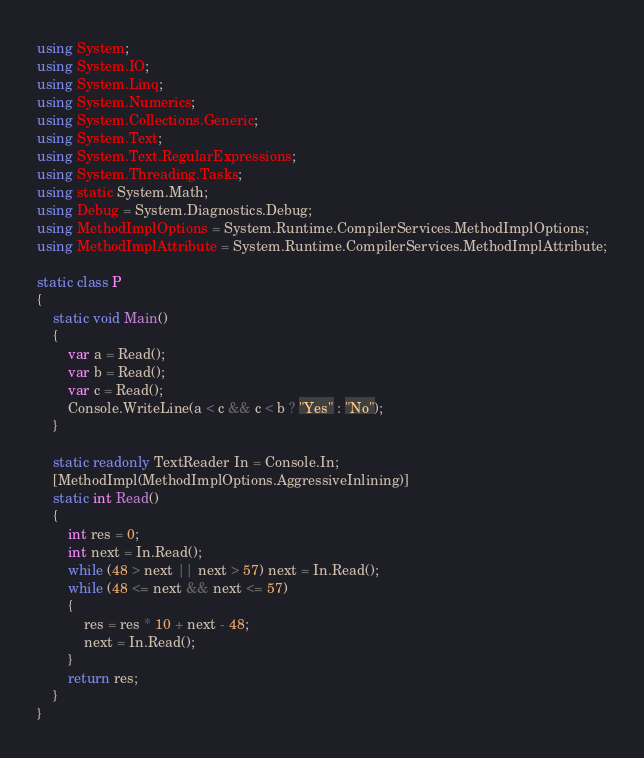Convert code to text. <code><loc_0><loc_0><loc_500><loc_500><_C#_>using System;
using System.IO;
using System.Linq;
using System.Numerics;
using System.Collections.Generic;
using System.Text;
using System.Text.RegularExpressions;
using System.Threading.Tasks;
using static System.Math;
using Debug = System.Diagnostics.Debug;
using MethodImplOptions = System.Runtime.CompilerServices.MethodImplOptions;
using MethodImplAttribute = System.Runtime.CompilerServices.MethodImplAttribute;

static class P
{
    static void Main()
    {
        var a = Read();   
        var b = Read();   
        var c = Read();
        Console.WriteLine(a < c && c < b ? "Yes" : "No");
    }

    static readonly TextReader In = Console.In;
    [MethodImpl(MethodImplOptions.AggressiveInlining)]
    static int Read()
    {
        int res = 0;
        int next = In.Read();
        while (48 > next || next > 57) next = In.Read();
        while (48 <= next && next <= 57)
        {
            res = res * 10 + next - 48;
            next = In.Read();
        }
        return res;
    }
}
</code> 